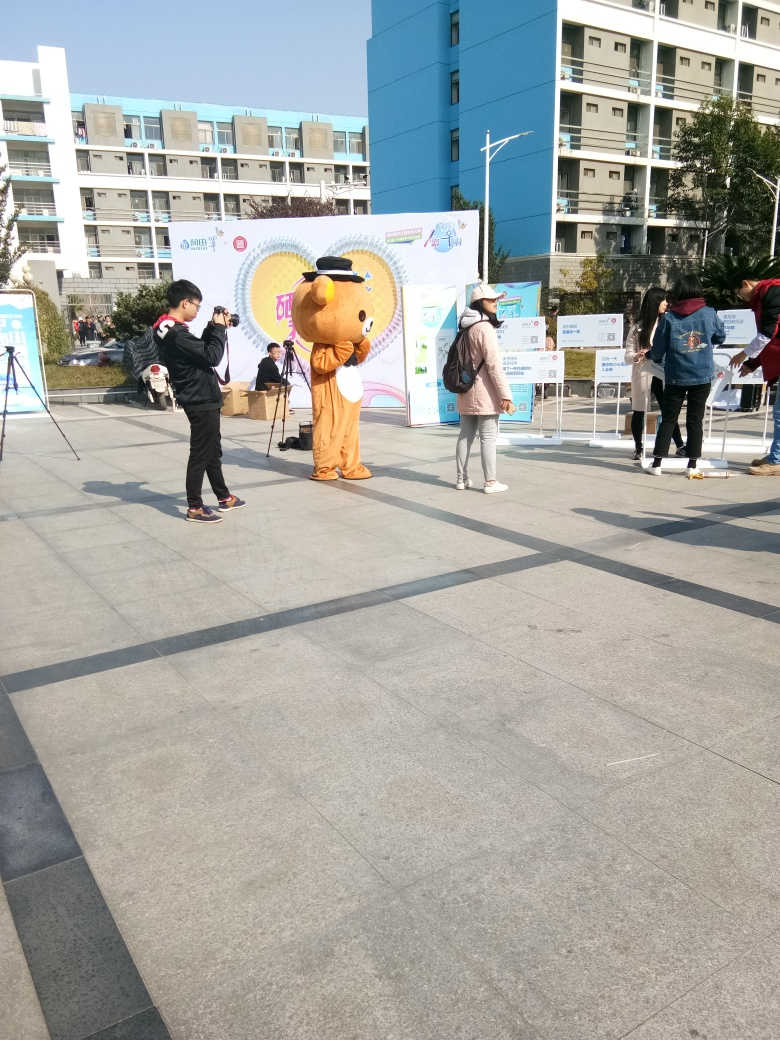Describe the atmosphere of the setting. The setting is outdoors in an open space, likely within a campus or public event area. People are mingling and appear to be in a casual, relaxed mood, suggesting a friendly and welcoming atmosphere at the gathering. 